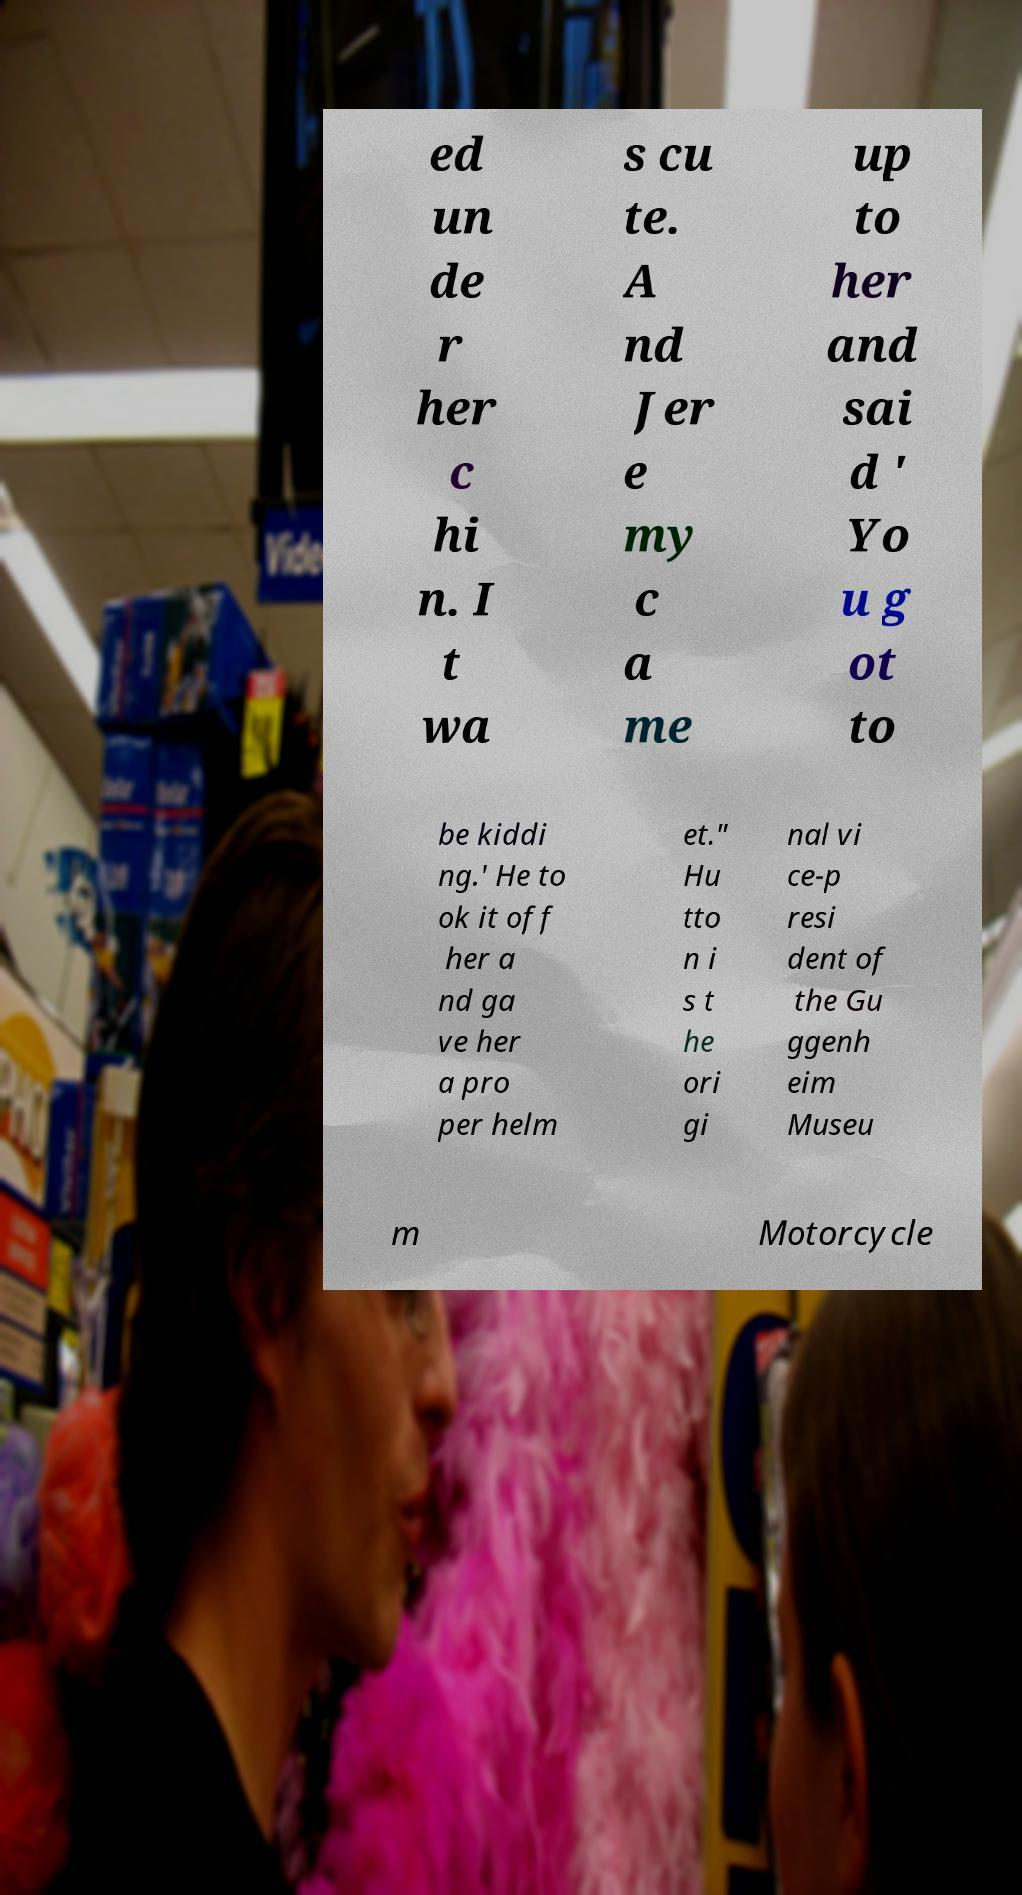Can you accurately transcribe the text from the provided image for me? ed un de r her c hi n. I t wa s cu te. A nd Jer e my c a me up to her and sai d ' Yo u g ot to be kiddi ng.' He to ok it off her a nd ga ve her a pro per helm et." Hu tto n i s t he ori gi nal vi ce-p resi dent of the Gu ggenh eim Museu m Motorcycle 